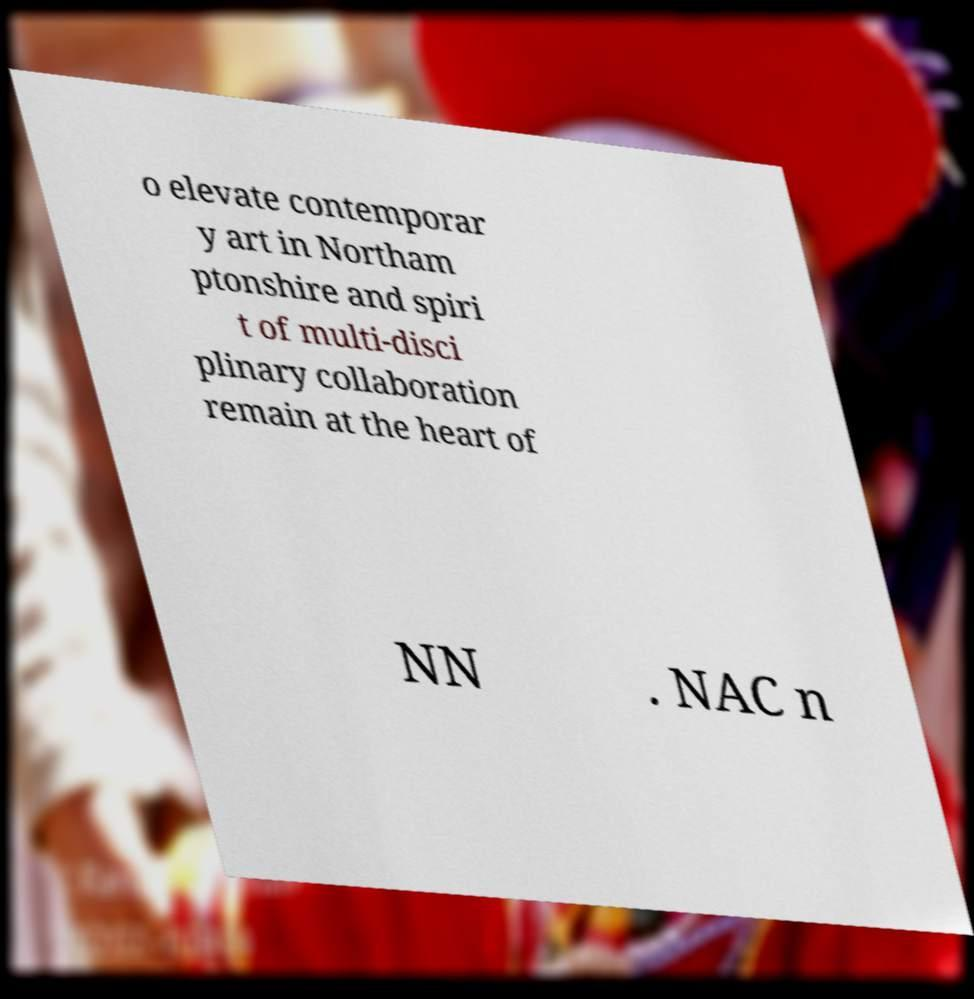For documentation purposes, I need the text within this image transcribed. Could you provide that? o elevate contemporar y art in Northam ptonshire and spiri t of multi-disci plinary collaboration remain at the heart of NN . NAC n 